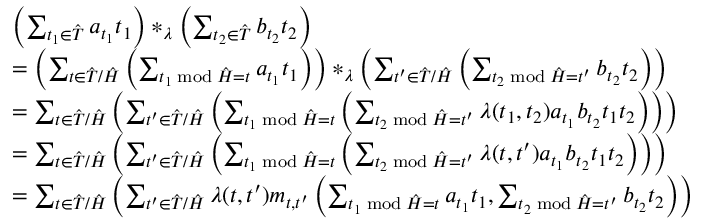Convert formula to latex. <formula><loc_0><loc_0><loc_500><loc_500>\begin{array} { r l } & { \left ( \sum _ { t _ { 1 } \in \hat { T } } a _ { t _ { 1 } } t _ { 1 } \right ) \ast _ { \lambda } \left ( \sum _ { t _ { 2 } \in \hat { T } } b _ { t _ { 2 } } t _ { 2 } \right ) } \\ & { = \left ( \sum _ { t \in \hat { T } / \hat { H } } \left ( \sum _ { t _ { 1 } \bmod \hat { H } = t } a _ { t _ { 1 } } t _ { 1 } \right ) \right ) \ast _ { \lambda } \left ( \sum _ { t ^ { \prime } \in \hat { T } / \hat { H } } \left ( \sum _ { t _ { 2 } \bmod \hat { H } = t ^ { \prime } } b _ { t _ { 2 } } t _ { 2 } \right ) \right ) } \\ & { = \sum _ { t \in \hat { T } / \hat { H } } \left ( \sum _ { t ^ { \prime } \in \hat { T } / \hat { H } } \left ( \sum _ { t _ { 1 } \bmod \hat { H } = t } \left ( \sum _ { t _ { 2 } \bmod \hat { H } = t ^ { \prime } } \lambda ( t _ { 1 } , t _ { 2 } ) a _ { t _ { 1 } } b _ { t _ { 2 } } t _ { 1 } t _ { 2 } \right ) \right ) \right ) } \\ & { = \sum _ { t \in \hat { T } / \hat { H } } \left ( \sum _ { t ^ { \prime } \in \hat { T } / \hat { H } } \left ( \sum _ { t _ { 1 } \bmod \hat { H } = t } \left ( \sum _ { t _ { 2 } \bmod \hat { H } = t ^ { \prime } } \lambda ( t , t ^ { \prime } ) a _ { t _ { 1 } } b _ { t _ { 2 } } t _ { 1 } t _ { 2 } \right ) \right ) \right ) } \\ & { = \sum _ { t \in \hat { T } / \hat { H } } \left ( \sum _ { t ^ { \prime } \in \hat { T } / \hat { H } } \lambda ( t , t ^ { \prime } ) m _ { t , t ^ { \prime } } \left ( \sum _ { t _ { 1 } \bmod \hat { H } = t } a _ { t _ { 1 } } t _ { 1 } , \sum _ { t _ { 2 } \bmod \hat { H } = t ^ { \prime } } b _ { t _ { 2 } } t _ { 2 } \right ) \right ) } \end{array}</formula> 